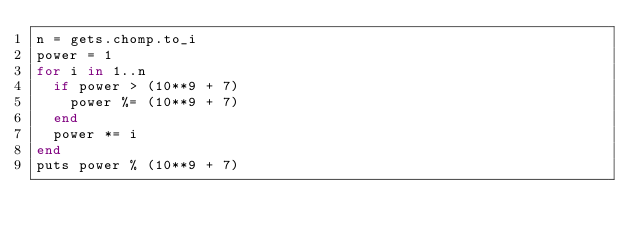<code> <loc_0><loc_0><loc_500><loc_500><_Ruby_>n = gets.chomp.to_i
power = 1
for i in 1..n
  if power > (10**9 + 7)
    power %= (10**9 + 7)
  end
  power *= i
end
puts power % (10**9 + 7)</code> 